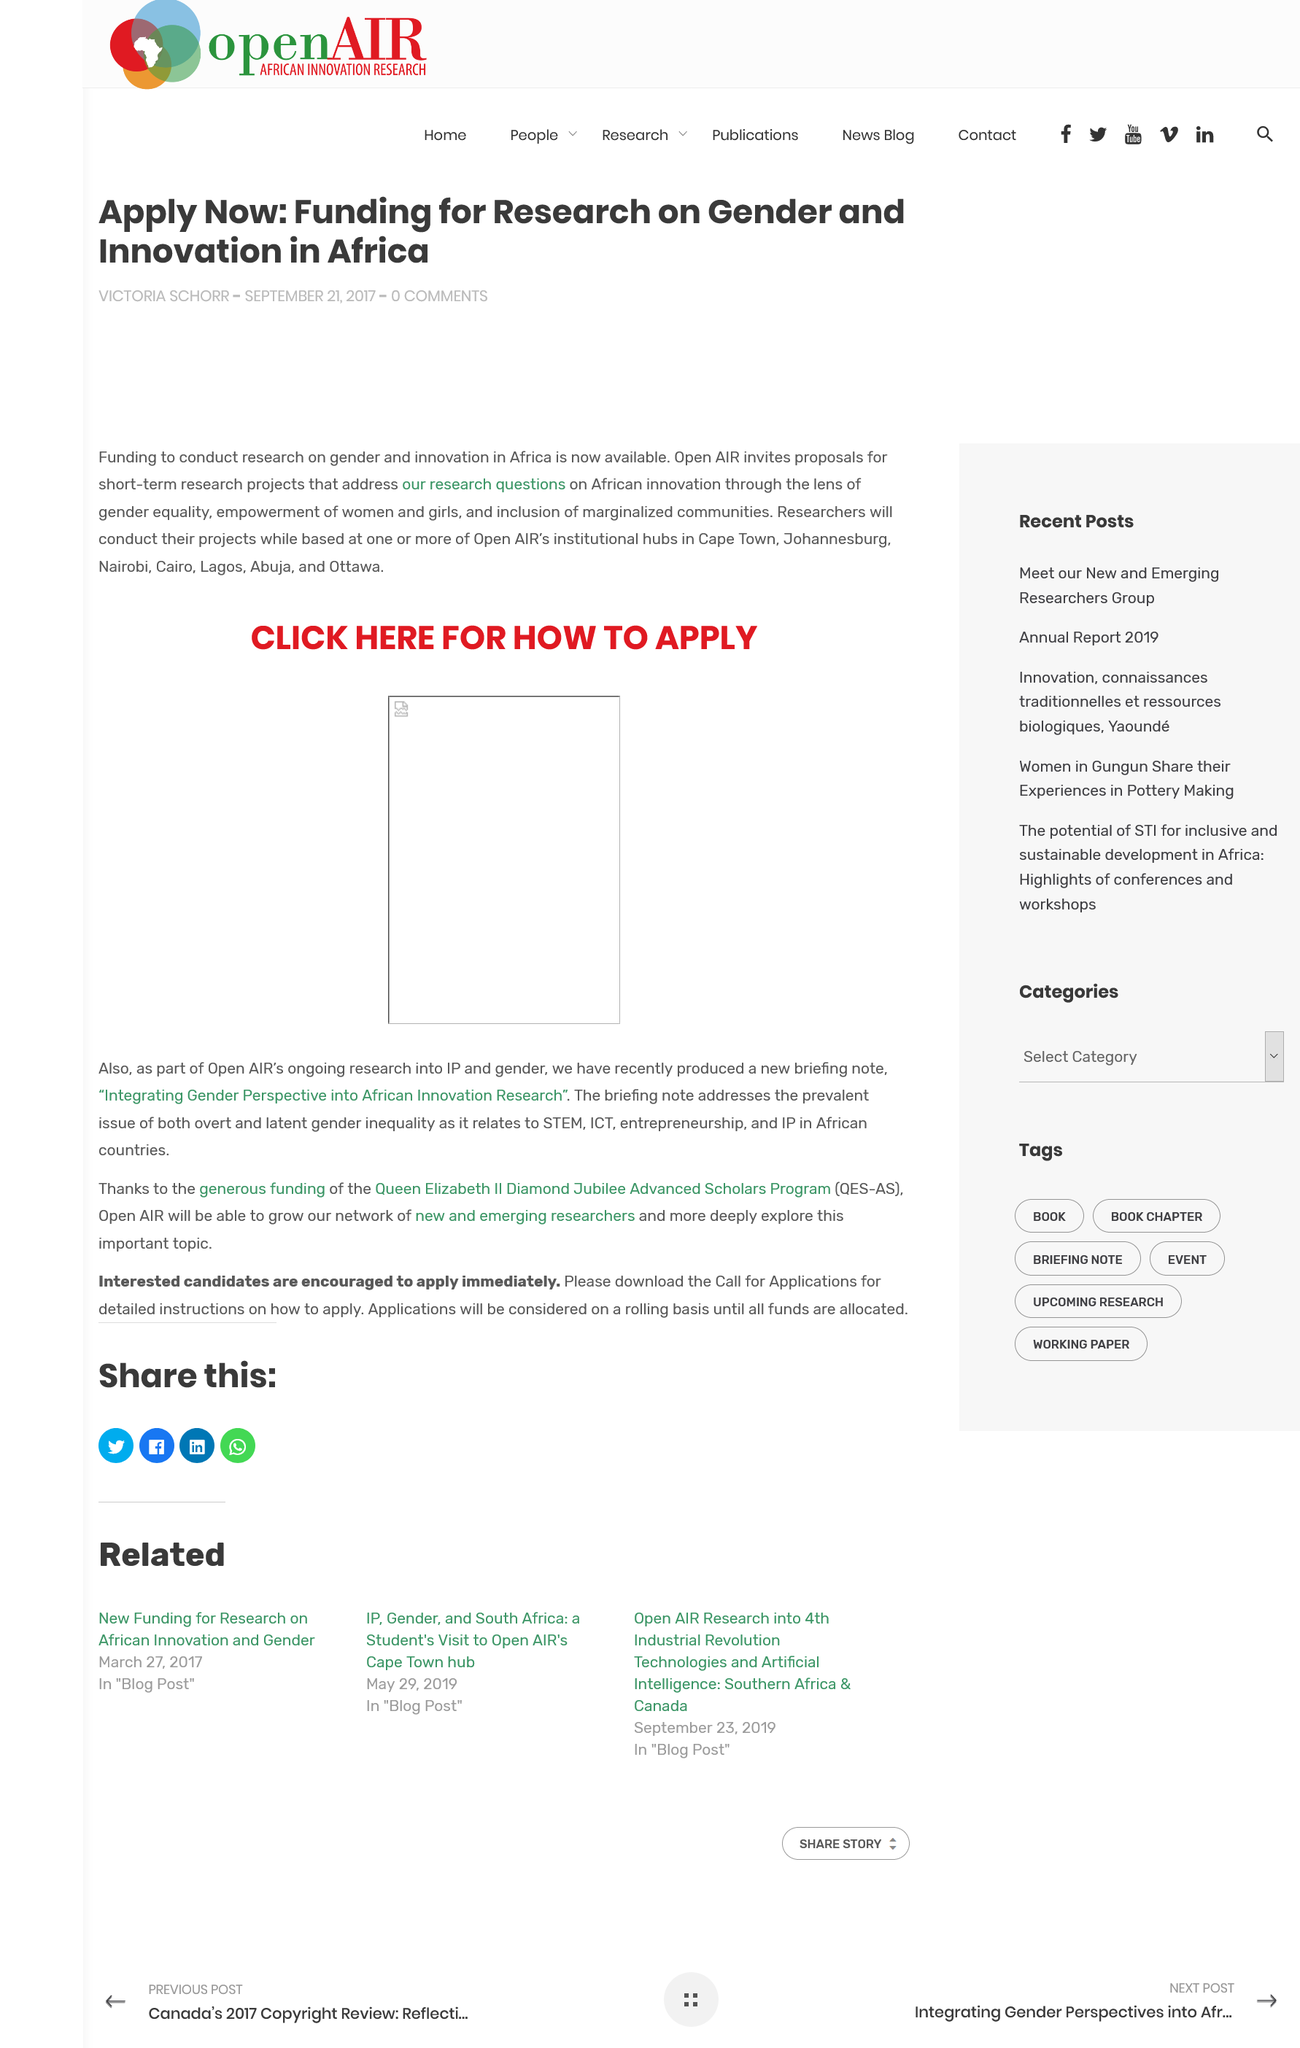Draw attention to some important aspects in this diagram. The article "Apply Now" mentions the country of Africa. The article "Apply Now" was written by Victoria Schorr. The article "Apply Now" was published on September 21, 2017. 